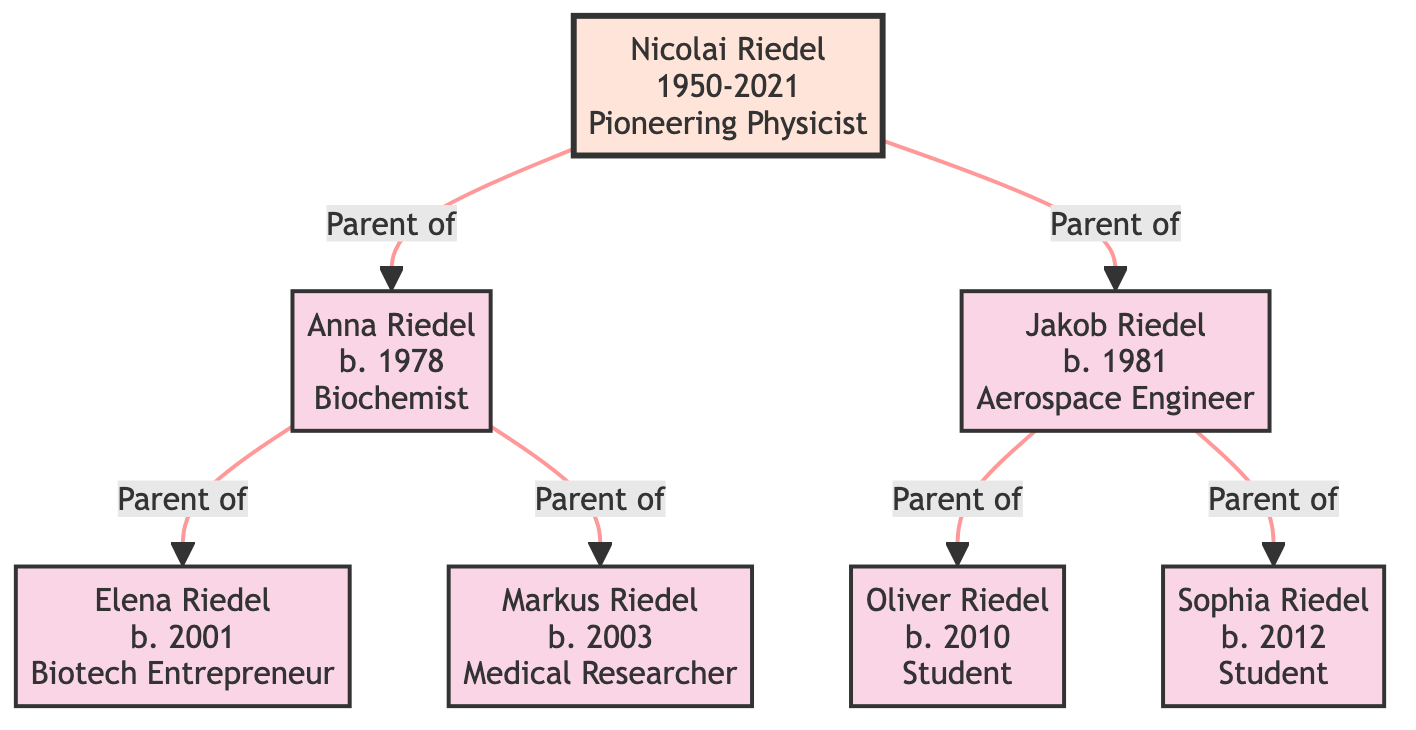What is Nicolai Riedel's occupation? The diagram indicates that Nicolai Riedel is a "Pioneering Physicist." This information is clearly stated in the node representing him.
Answer: Pioneering Physicist How many children does Nicolai Riedel have? By examining the diagram, Nicolai Riedel has two children listed: Anna Riedel and Jakob Riedel. Therefore, the count of children is two.
Answer: 2 What major achievement did Anna Riedel accomplish? The diagram shows that Anna Riedel achieved the "Nobel Prize in Chemistry." This achievement is specifically listed under her details.
Answer: Nobel Prize in Chemistry Who is the youngest Riedel descendant? Oliver Riedel is born in 2010, while Sophia Riedel is born in 2012. Since both are children of Jakob Riedel, and Oliver is the first mentioned, he is the younger sibling. Therefore, Sophia Riedel is the youngest among Nicolai's grandchildren.
Answer: Sophia Riedel What is the occupation of Markus Riedel? The diagram specifies that Markus Riedel's occupation is "Medical Researcher." This information is provided directly in his node.
Answer: Medical Researcher Which descendant is involved in biotechnology? The diagram indicates that Elena Riedel, the daughter of Anna Riedel, is a "Biotech Entrepreneur." By following the lineage from Nicolai to Anna and then to Elena, we identify her role.
Answer: Elena Riedel How many achievements does Jakob Riedel have listed? Jakob Riedel is noted to have two achievements: "Lead Engineer at NASA" and "Inventor of the Riedel Propulsion System." Counting these achievements gives us a total of two.
Answer: 2 Which child of Nicolai Riedel is born first? By comparing the birth years of his children, Anna Riedel (1978) and Jakob Riedel (1981), we find that Anna was born first in 1978, making her the elder child.
Answer: Anna Riedel What notable work is attributed to Nicolai Riedel? The diagram mentions two notable works associated with Nicolai Riedel: "Riedel Constant" and "Quantum Mechanics Theory." These are explicitly noted in his details.
Answer: Riedel Constant, Quantum Mechanics Theory 